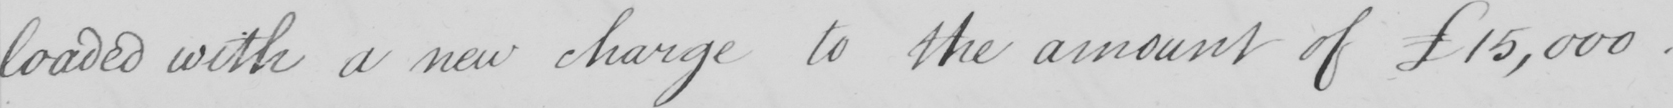Can you tell me what this handwritten text says? loaded with a new charge to the amount of £15,000 . 